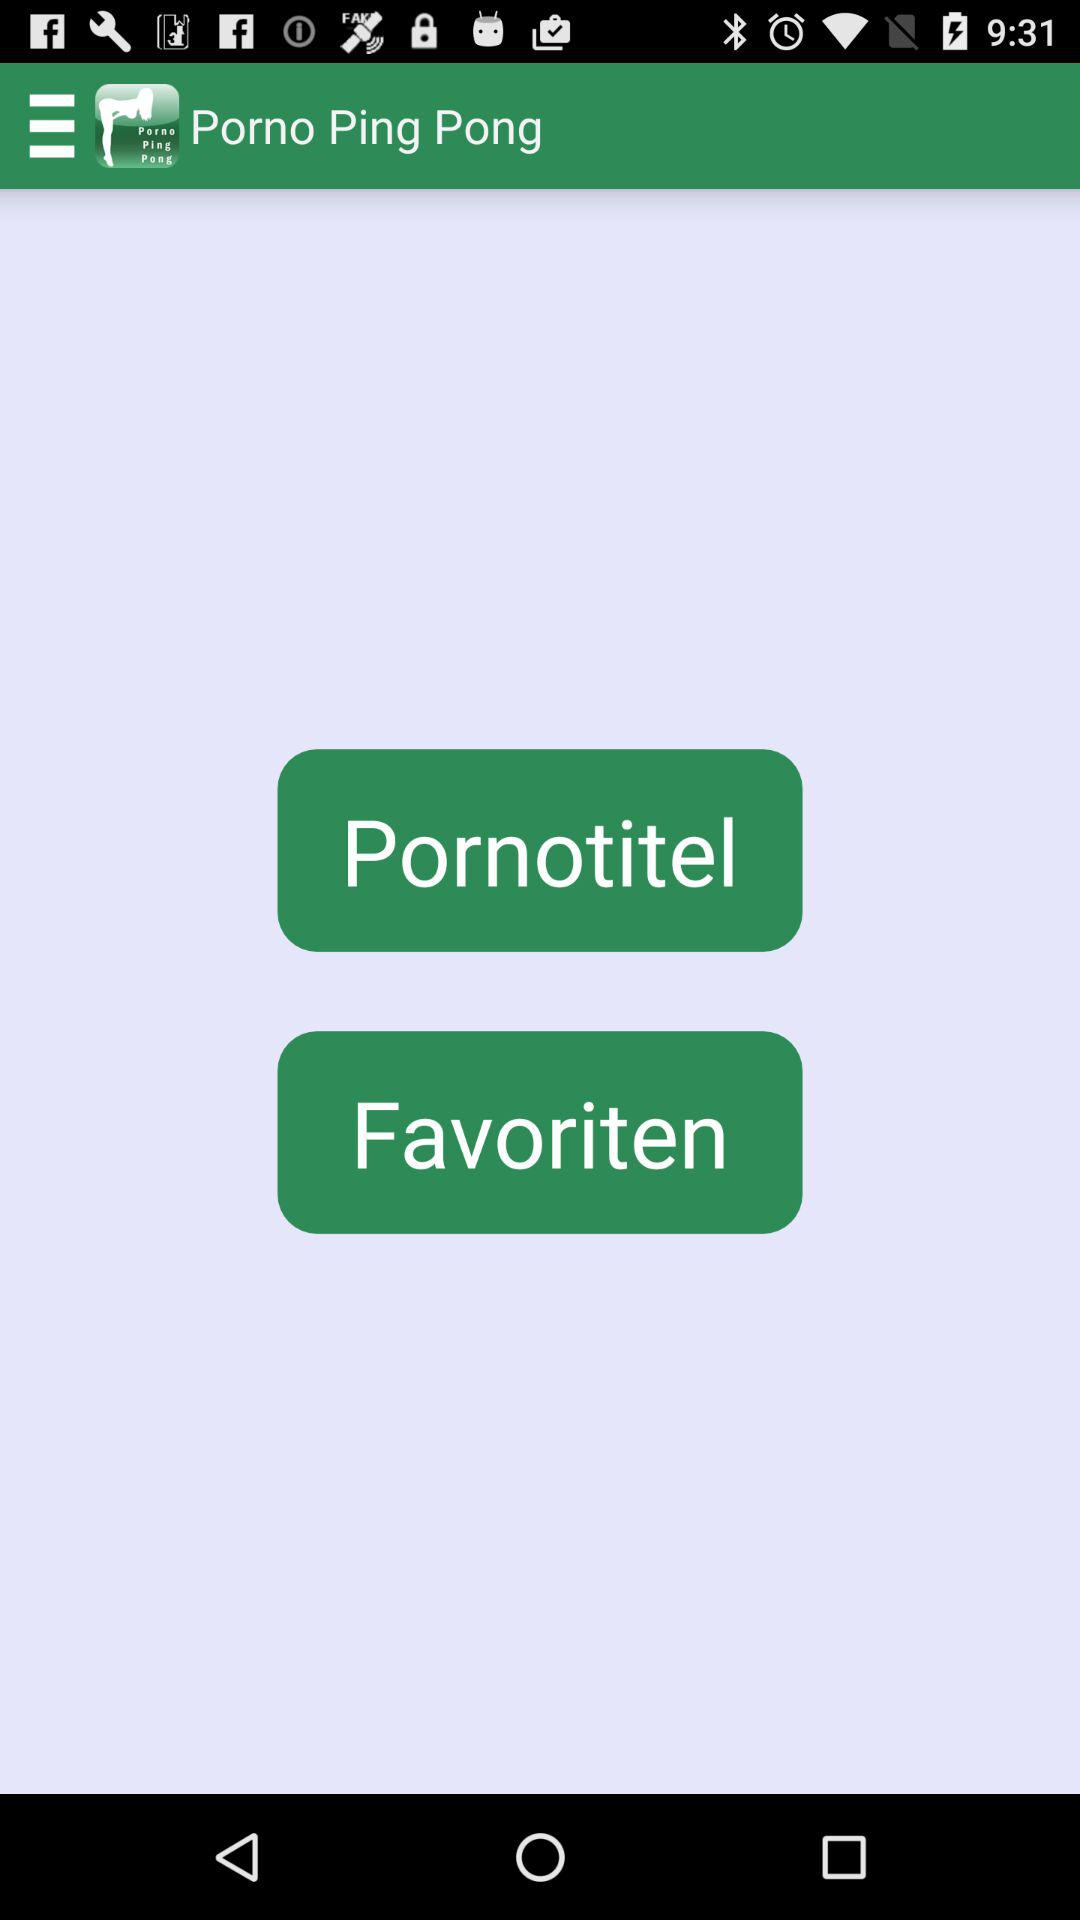What is the name of the application? The name of the application is "Porno Ping Pong". 